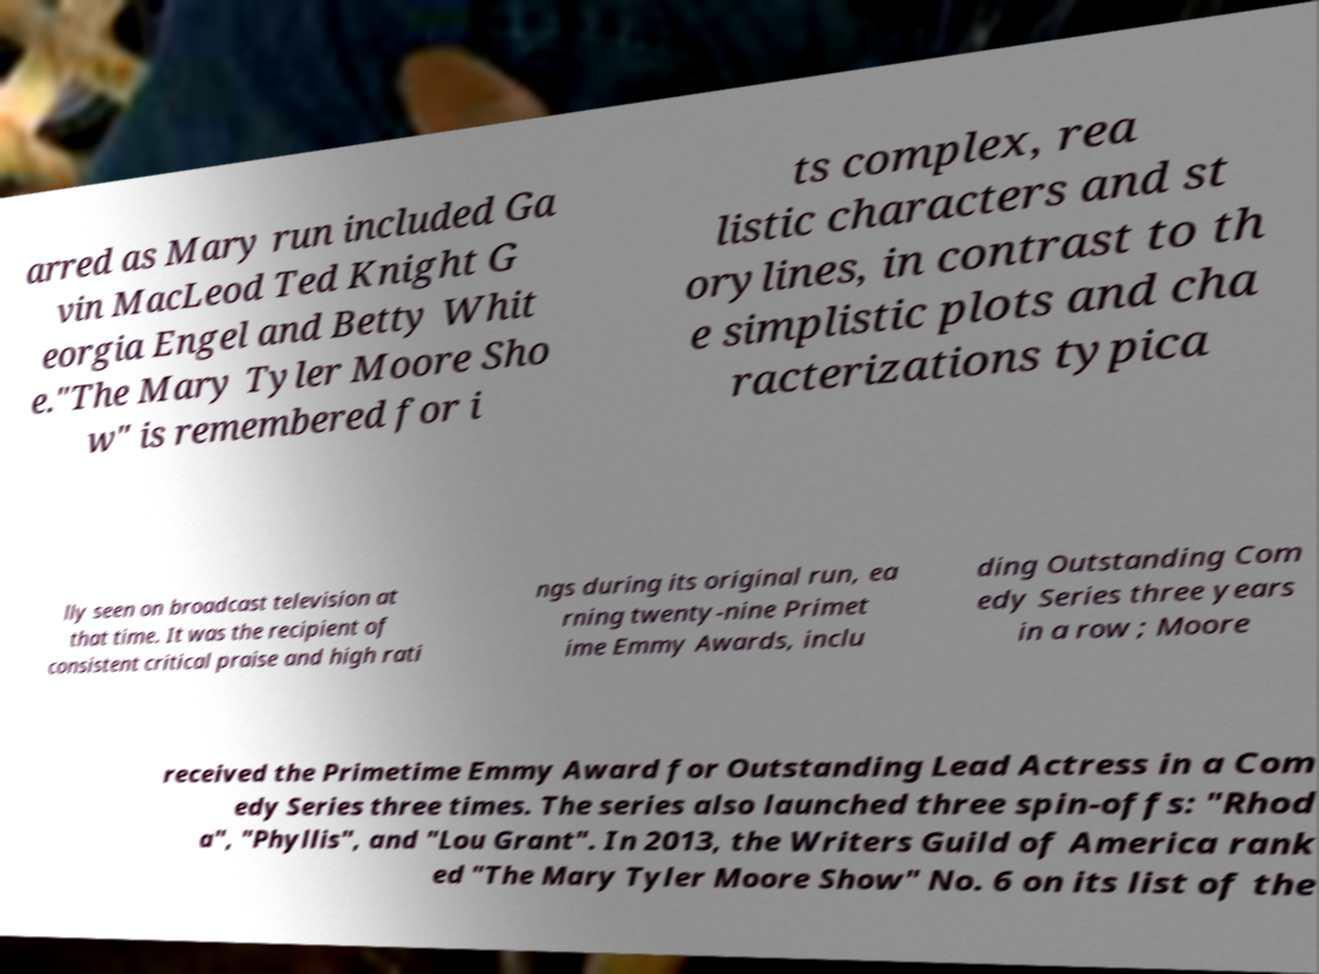I need the written content from this picture converted into text. Can you do that? arred as Mary run included Ga vin MacLeod Ted Knight G eorgia Engel and Betty Whit e."The Mary Tyler Moore Sho w" is remembered for i ts complex, rea listic characters and st orylines, in contrast to th e simplistic plots and cha racterizations typica lly seen on broadcast television at that time. It was the recipient of consistent critical praise and high rati ngs during its original run, ea rning twenty-nine Primet ime Emmy Awards, inclu ding Outstanding Com edy Series three years in a row ; Moore received the Primetime Emmy Award for Outstanding Lead Actress in a Com edy Series three times. The series also launched three spin-offs: "Rhod a", "Phyllis", and "Lou Grant". In 2013, the Writers Guild of America rank ed "The Mary Tyler Moore Show" No. 6 on its list of the 